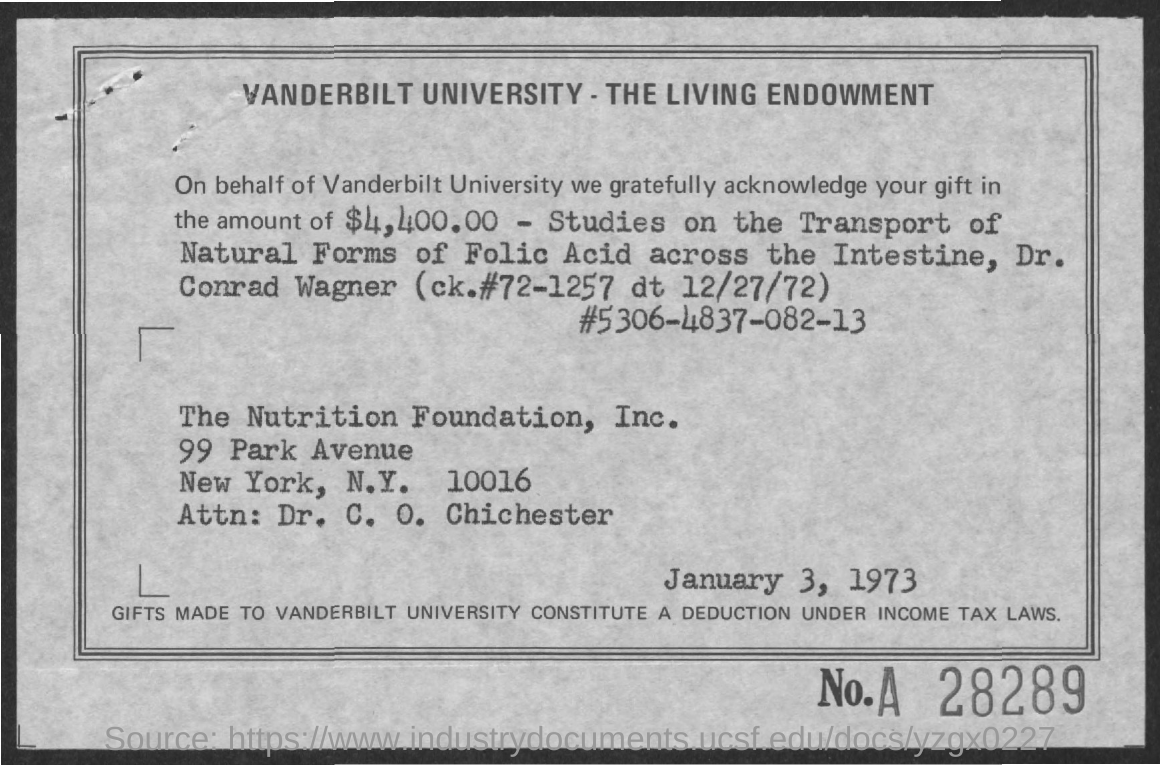What is the value of the gifted amount mentioned in the given page ?
Keep it short and to the point. $ 4,400.00. On what purpose the amount was gifted ?
Provide a short and direct response. Studies on the Transport of Natural Forms of Folic Acid across the Intestine. 